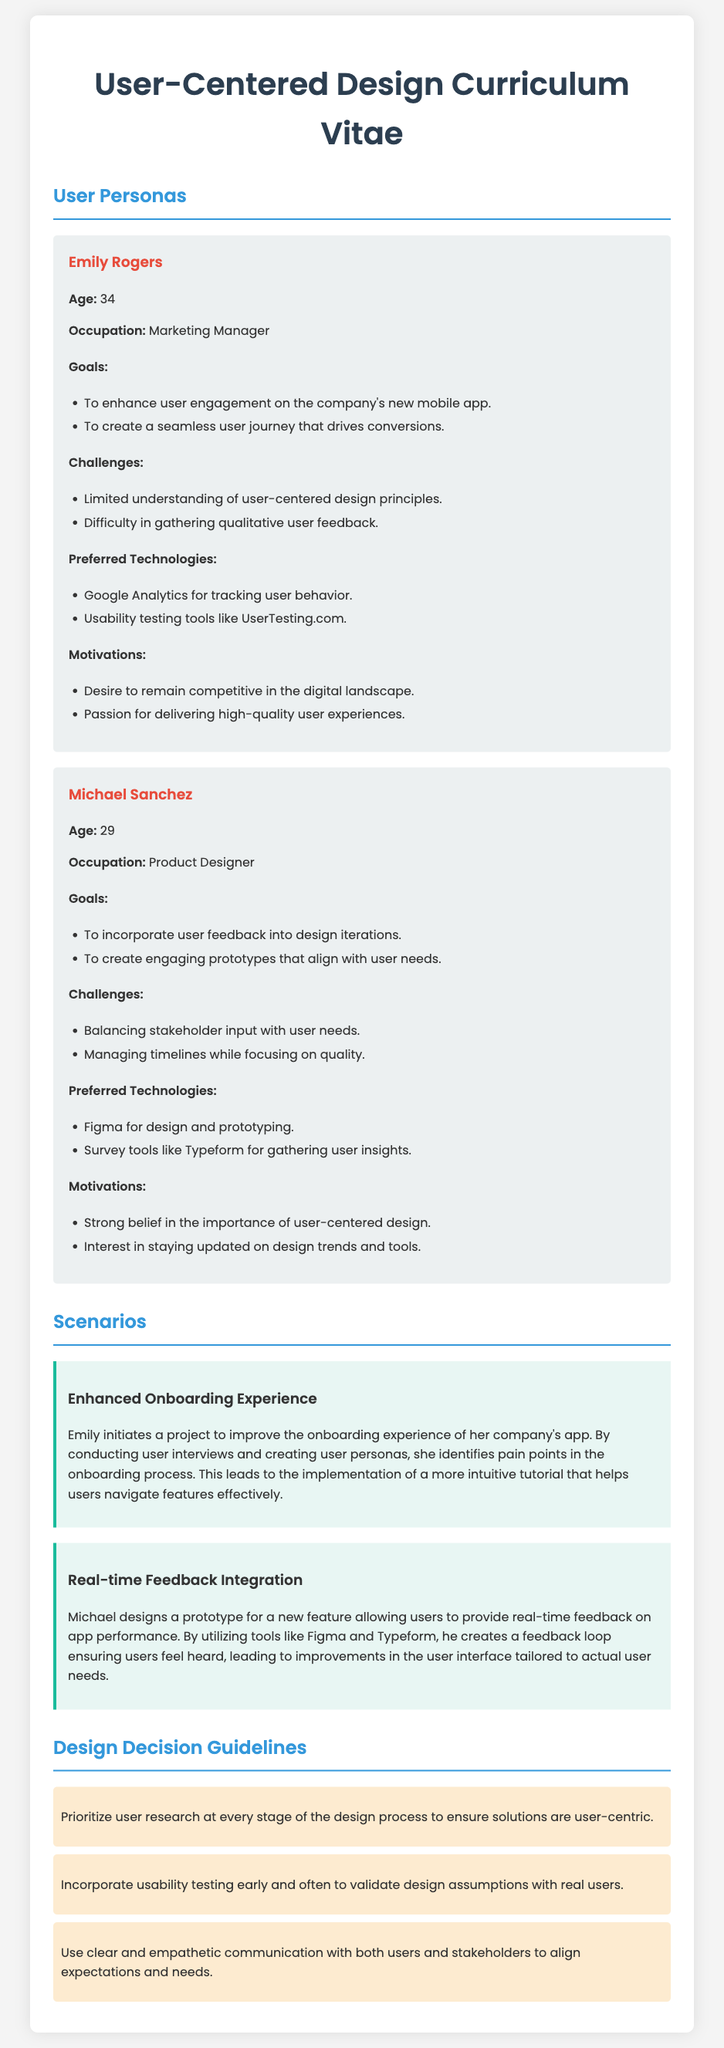what is the age of Emily Rogers? The document states that Emily Rogers is 34 years old.
Answer: 34 what is Michael Sanchez's occupation? According to the document, Michael Sanchez works as a Product Designer.
Answer: Product Designer what is one of Emily Rogers' goals? The document lists that one of her goals is to enhance user engagement on the company's new mobile app.
Answer: Enhance user engagement on the company's new mobile app which tool does Michael prefer for design and prototyping? The document mentions that Michael prefers Figma for design and prototyping.
Answer: Figma what is the primary challenge Emily Rogers faces? The document indicates that Emily has limited understanding of user-centered design principles as one of her challenges.
Answer: Limited understanding of user-centered design principles what is the focus of the scenario titled "Enhanced Onboarding Experience"? The scenario discusses improving the onboarding experience of the app through user interviews and the creation of user personas.
Answer: Improving onboarding experience through user interviews and personas how does Michael gather user insights? The document states that Michael uses survey tools like Typeform for gathering user insights.
Answer: Survey tools like Typeform what is one guideline for design decisions mentioned in the document? The document specifies that one guideline is to prioritize user research at every stage of the design process.
Answer: Prioritize user research at every stage of the design process 